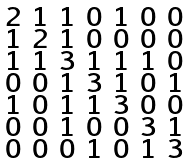<formula> <loc_0><loc_0><loc_500><loc_500>\begin{smallmatrix} 2 & 1 & 1 & 0 & 1 & 0 & 0 \\ 1 & 2 & 1 & 0 & 0 & 0 & 0 \\ 1 & 1 & 3 & 1 & 1 & 1 & 0 \\ 0 & 0 & 1 & 3 & 1 & 0 & 1 \\ 1 & 0 & 1 & 1 & 3 & 0 & 0 \\ 0 & 0 & 1 & 0 & 0 & 3 & 1 \\ 0 & 0 & 0 & 1 & 0 & 1 & 3 \end{smallmatrix}</formula> 